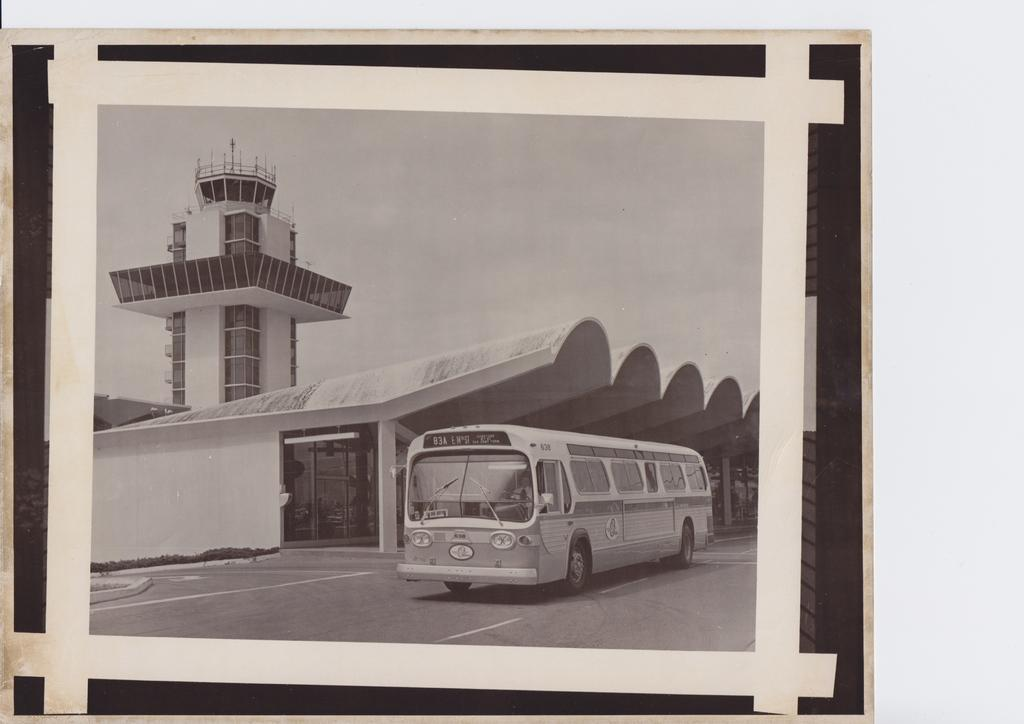What is the color scheme of the image? The image is black and white. What mode of transportation can be seen in the image? There is a bus in the image. What type of structure is present in the image? There is a building and a tower in the image. What is the setting of the image? There is a road in the image, suggesting an urban or suburban setting. What is visible in the background of the image? The sky is visible in the image. What is the income of the person driving the bus in the image? There is no information about the income of the person driving the bus in the image, nor is there any indication of a person driving the bus. 